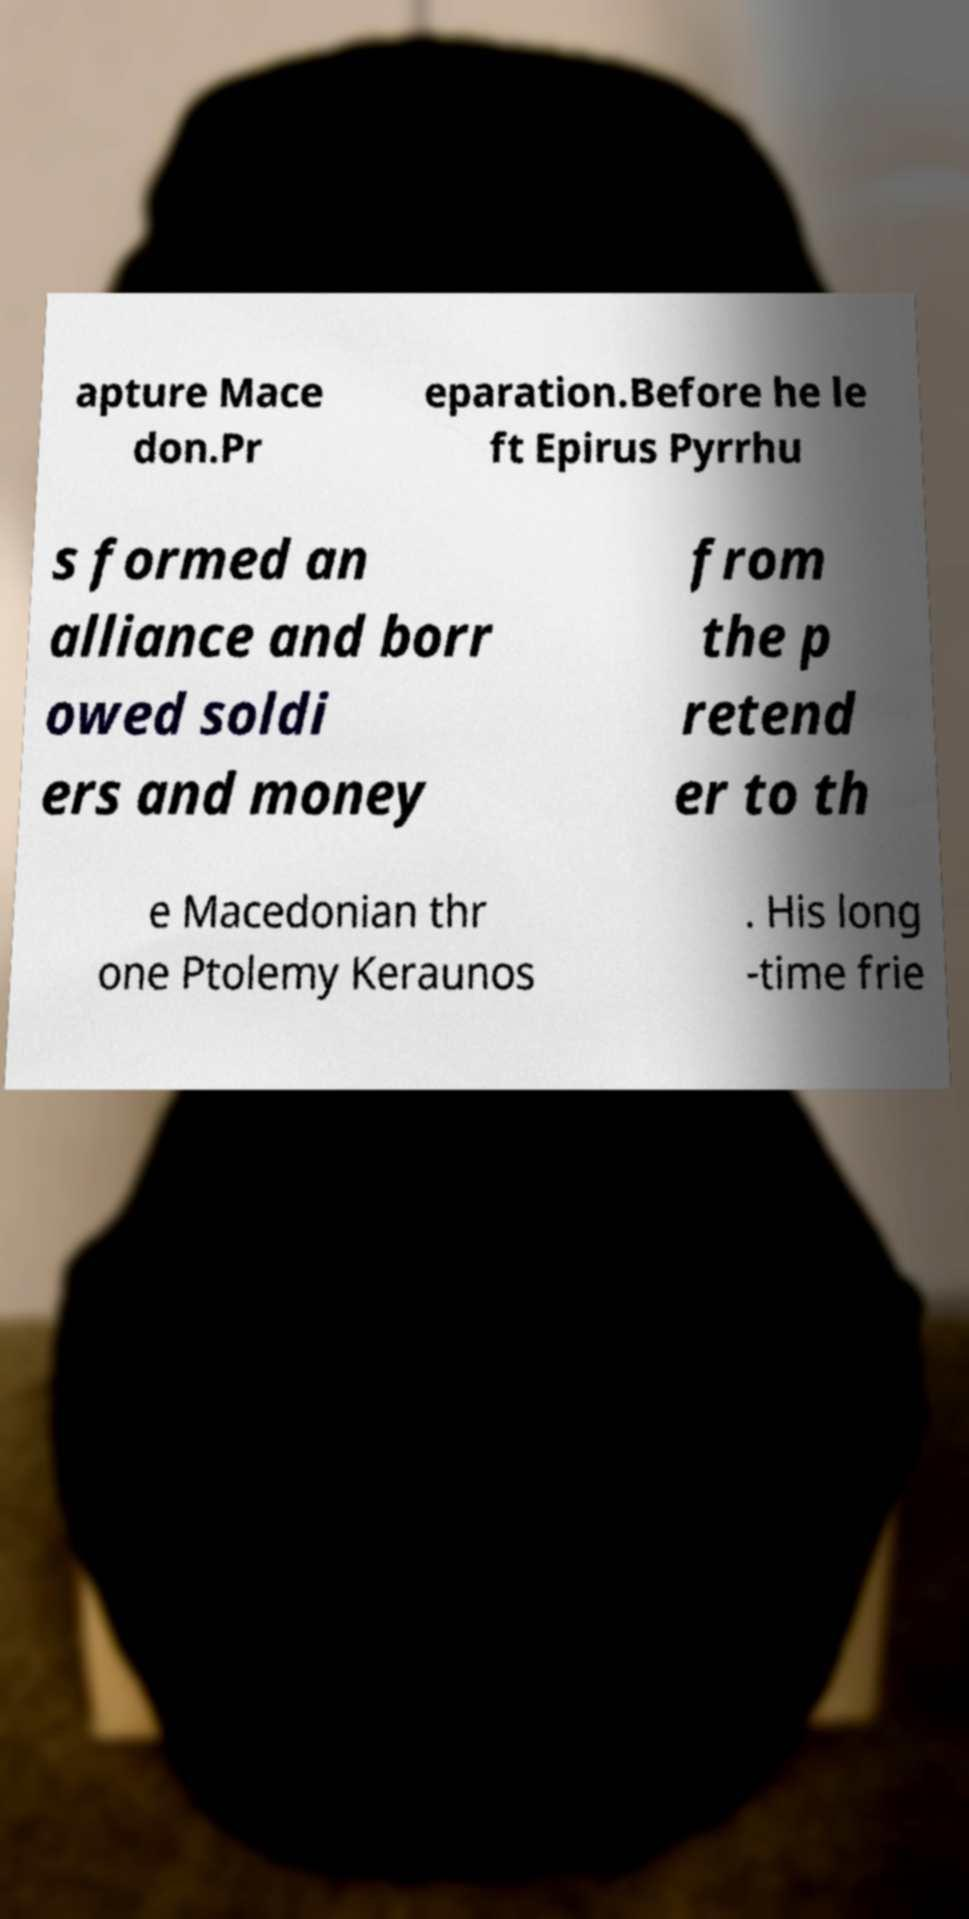Can you accurately transcribe the text from the provided image for me? apture Mace don.Pr eparation.Before he le ft Epirus Pyrrhu s formed an alliance and borr owed soldi ers and money from the p retend er to th e Macedonian thr one Ptolemy Keraunos . His long -time frie 